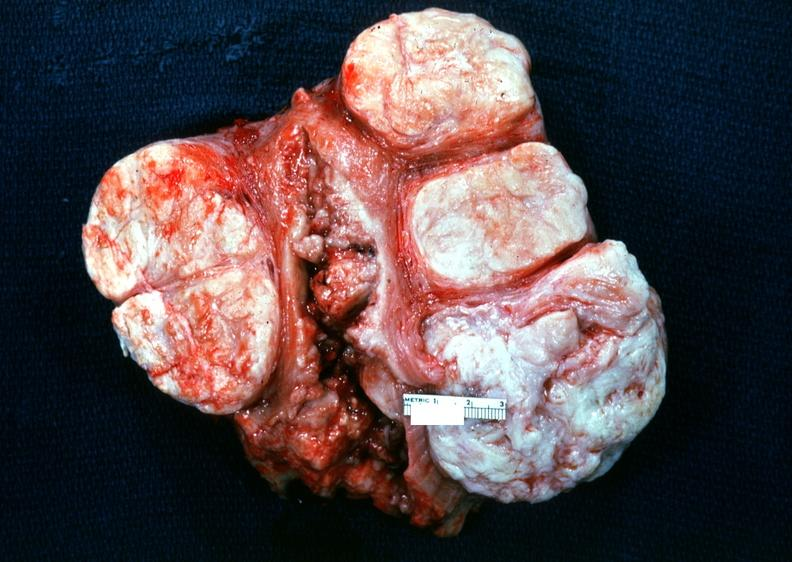does retroperitoneal liposarcoma show uterus, leiomyoma?
Answer the question using a single word or phrase. No 